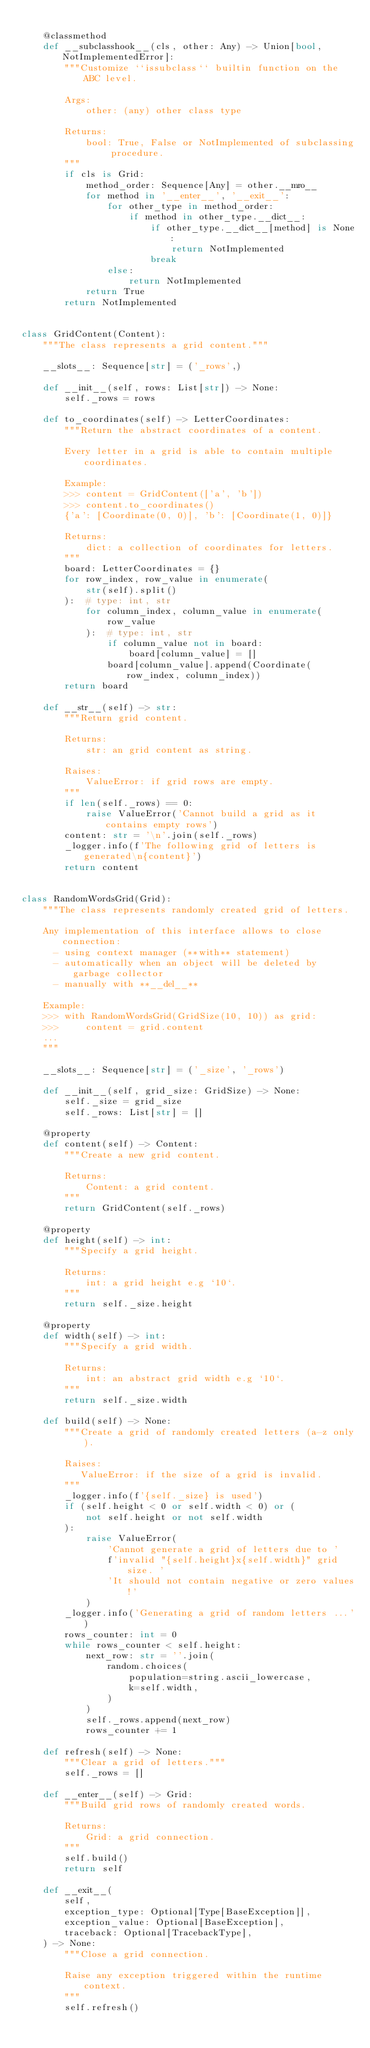Convert code to text. <code><loc_0><loc_0><loc_500><loc_500><_Python_>
    @classmethod
    def __subclasshook__(cls, other: Any) -> Union[bool, NotImplementedError]:
        """Customize ``issubclass`` builtin function on the ABC level.

        Args:
            other: (any) other class type

        Returns:
            bool: True, False or NotImplemented of subclassing procedure.
        """
        if cls is Grid:
            method_order: Sequence[Any] = other.__mro__
            for method in '__enter__', '__exit__':
                for other_type in method_order:
                    if method in other_type.__dict__:
                        if other_type.__dict__[method] is None:
                            return NotImplemented
                        break
                else:
                    return NotImplemented
            return True
        return NotImplemented


class GridContent(Content):
    """The class represents a grid content."""

    __slots__: Sequence[str] = ('_rows',)

    def __init__(self, rows: List[str]) -> None:
        self._rows = rows

    def to_coordinates(self) -> LetterCoordinates:
        """Return the abstract coordinates of a content.

        Every letter in a grid is able to contain multiple coordinates.

        Example:
        >>> content = GridContent(['a', 'b'])
        >>> content.to_coordinates()
        {'a': [Coordinate(0, 0)], 'b': [Coordinate(1, 0)]}

        Returns:
            dict: a collection of coordinates for letters.
        """
        board: LetterCoordinates = {}
        for row_index, row_value in enumerate(
            str(self).split()
        ):  # type: int, str
            for column_index, column_value in enumerate(
                row_value
            ):  # type: int, str
                if column_value not in board:
                    board[column_value] = []
                board[column_value].append(Coordinate(row_index, column_index))
        return board

    def __str__(self) -> str:
        """Return grid content.

        Returns:
            str: an grid content as string.

        Raises:
            ValueError: if grid rows are empty.
        """
        if len(self._rows) == 0:
            raise ValueError('Cannot build a grid as it contains empty rows')
        content: str = '\n'.join(self._rows)
        _logger.info(f'The following grid of letters is generated\n{content}')
        return content


class RandomWordsGrid(Grid):
    """The class represents randomly created grid of letters.

    Any implementation of this interface allows to close connection:
      - using context manager (**with** statement)
      - automatically when an object will be deleted by garbage collector
      - manually with **__del__**

    Example:
    >>> with RandomWordsGrid(GridSize(10, 10)) as grid:
    >>>     content = grid.content
    ...
    """

    __slots__: Sequence[str] = ('_size', '_rows')

    def __init__(self, grid_size: GridSize) -> None:
        self._size = grid_size
        self._rows: List[str] = []

    @property
    def content(self) -> Content:
        """Create a new grid content.

        Returns:
            Content: a grid content.
        """
        return GridContent(self._rows)

    @property
    def height(self) -> int:
        """Specify a grid height.

        Returns:
            int: a grid height e.g `10`.
        """
        return self._size.height

    @property
    def width(self) -> int:
        """Specify a grid width.

        Returns:
            int: an abstract grid width e.g `10`.
        """
        return self._size.width

    def build(self) -> None:
        """Create a grid of randomly created letters (a-z only).

        Raises:
           ValueError: if the size of a grid is invalid.
        """
        _logger.info(f'{self._size} is used')
        if (self.height < 0 or self.width < 0) or (
            not self.height or not self.width
        ):
            raise ValueError(
                'Cannot generate a grid of letters due to '
                f'invalid "{self.height}x{self.width}" grid size. '
                'It should not contain negative or zero values!'
            )
        _logger.info('Generating a grid of random letters ...')
        rows_counter: int = 0
        while rows_counter < self.height:
            next_row: str = ''.join(
                random.choices(
                    population=string.ascii_lowercase,
                    k=self.width,
                )
            )
            self._rows.append(next_row)
            rows_counter += 1

    def refresh(self) -> None:
        """Clear a grid of letters."""
        self._rows = []

    def __enter__(self) -> Grid:
        """Build grid rows of randomly created words.

        Returns:
            Grid: a grid connection.
        """
        self.build()
        return self

    def __exit__(
        self,
        exception_type: Optional[Type[BaseException]],
        exception_value: Optional[BaseException],
        traceback: Optional[TracebackType],
    ) -> None:
        """Close a grid connection.

        Raise any exception triggered within the runtime context.
        """
        self.refresh()
</code> 